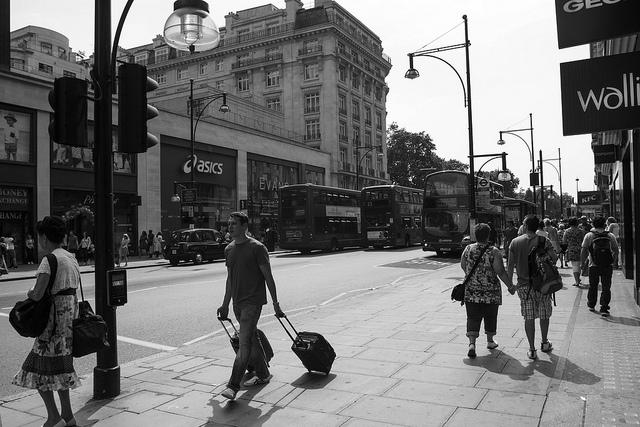How many people are holding a surfboard?
Quick response, please. 0. What store sign is across the street?
Answer briefly. Asics. What color is the photo?
Give a very brief answer. Black and white. Is there a dog in the photo?
Short answer required. No. What does the man have inside his suitcases?
Short answer required. Clothes. Is this a construction zone?
Quick response, please. No. 